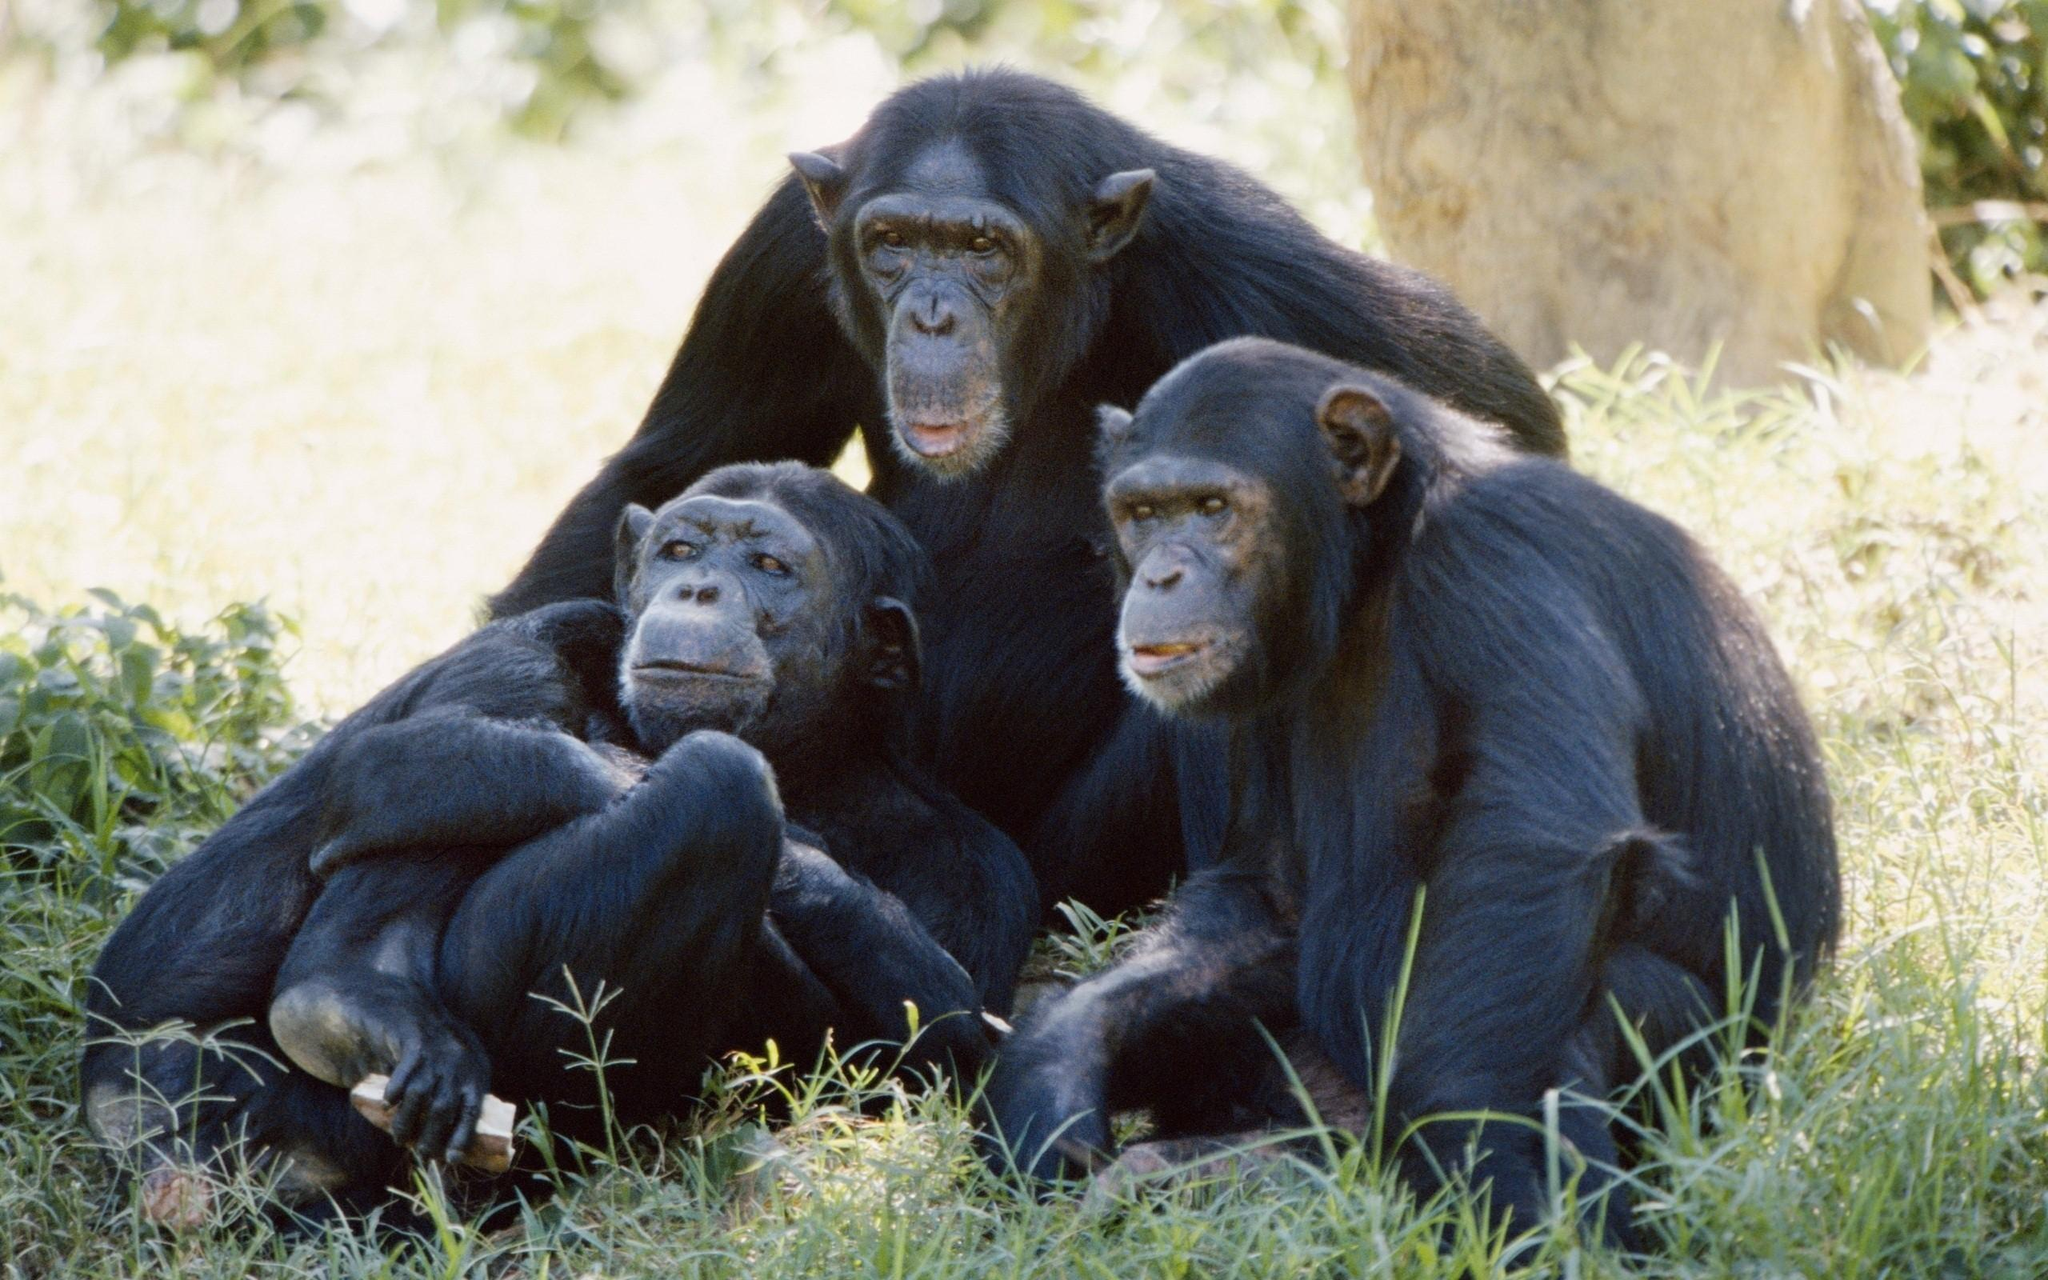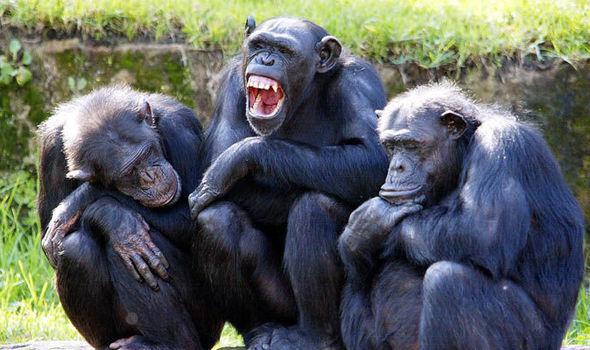The first image is the image on the left, the second image is the image on the right. Analyze the images presented: Is the assertion "The right image features three apes side by side, all sitting crouched with bent knees." valid? Answer yes or no. Yes. 